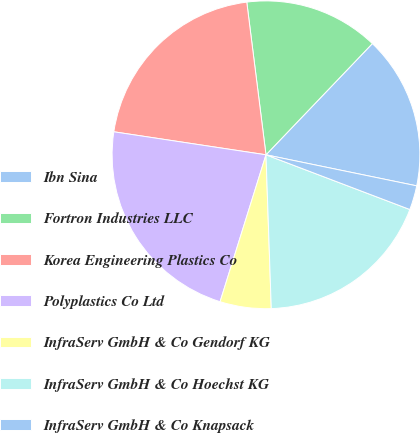Convert chart to OTSL. <chart><loc_0><loc_0><loc_500><loc_500><pie_chart><fcel>Ibn Sina<fcel>Fortron Industries LLC<fcel>Korea Engineering Plastics Co<fcel>Polyplastics Co Ltd<fcel>InfraServ GmbH & Co Gendorf KG<fcel>InfraServ GmbH & Co Hoechst KG<fcel>InfraServ GmbH & Co Knapsack<nl><fcel>16.09%<fcel>14.14%<fcel>20.62%<fcel>22.57%<fcel>5.37%<fcel>18.67%<fcel>2.55%<nl></chart> 